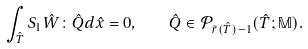<formula> <loc_0><loc_0><loc_500><loc_500>\int _ { \hat { T } } S _ { 1 } \hat { W } \colon \hat { Q } d \hat { x } = 0 , \quad \hat { Q } \in \mathcal { P } _ { \tilde { r } ( \hat { T } ) - 1 } ( \hat { T } ; \mathbb { M } ) .</formula> 